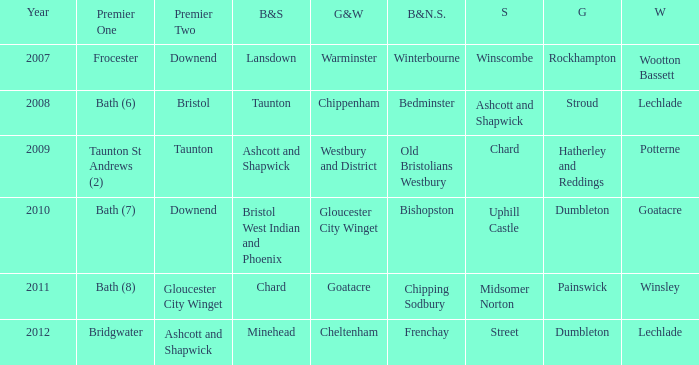Would you mind parsing the complete table? {'header': ['Year', 'Premier One', 'Premier Two', 'B&S', 'G&W', 'B&N.S.', 'S', 'G', 'W'], 'rows': [['2007', 'Frocester', 'Downend', 'Lansdown', 'Warminster', 'Winterbourne', 'Winscombe', 'Rockhampton', 'Wootton Bassett'], ['2008', 'Bath (6)', 'Bristol', 'Taunton', 'Chippenham', 'Bedminster', 'Ashcott and Shapwick', 'Stroud', 'Lechlade'], ['2009', 'Taunton St Andrews (2)', 'Taunton', 'Ashcott and Shapwick', 'Westbury and District', 'Old Bristolians Westbury', 'Chard', 'Hatherley and Reddings', 'Potterne'], ['2010', 'Bath (7)', 'Downend', 'Bristol West Indian and Phoenix', 'Gloucester City Winget', 'Bishopston', 'Uphill Castle', 'Dumbleton', 'Goatacre'], ['2011', 'Bath (8)', 'Gloucester City Winget', 'Chard', 'Goatacre', 'Chipping Sodbury', 'Midsomer Norton', 'Painswick', 'Winsley'], ['2012', 'Bridgwater', 'Ashcott and Shapwick', 'Minehead', 'Cheltenham', 'Frenchay', 'Street', 'Dumbleton', 'Lechlade']]} What is the bristol & n. som where the somerset is ashcott and shapwick? Bedminster. 